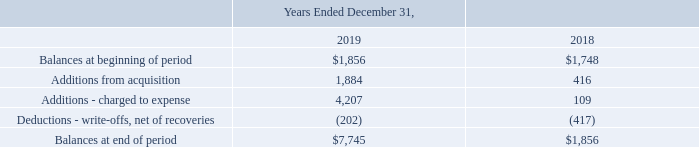ADVANCED ENERGY INDUSTRIES, INC. NOTES TO CONSOLIDATED FINANCIAL STATEMENTS – (continued) (in thousands, except per share amounts)
We have established an allowance for doubtful accounts based upon factors surrounding the credit risk of specific customers, historical trends, and other information.
Accounts Receivable and Allowance for Doubtful Accounts — Accounts receivable are recorded at net realizable value. We maintain a credit approval process and we make significant judgments in connection with assessing our customers’ ability to pay. Despite this assessment, from time to time, our customers are unable to meet their payment obligations. We continuously monitor our customers’ credit worthiness and use our judgment in establishing a provision for estimated credit losses based upon our historical experience and any specific customer collection issues that we have identified. While such credit losses have historically been within our expectations and the provisions established, there is no assurance that we will continue to experience the same credit loss rates that we have in the past. For example, in the fourth quarter, we increased our allowance for doubtful accounts by $4.2 million relating to a customer exposure in China resulting from economic softness and funding delays causing uncertainty in large program timing which uncertainty is now exacerbated by the spreading Coronavirus. A significant change in the liquidity or financial position of our customers could have a material adverse impact on the collectability of accounts receivable and our future operating results.
Changes in allowance for doubtful accounts are summarized as follows:
What was the balance at the beginning of the period of 2019?
Answer scale should be: thousand. $1,856. What was the  Additions from acquisition of 2018?
Answer scale should be: thousand. 1,884. How did the company establish an allowance for doubtful accounts? Based upon factors surrounding the credit risk of specific customers, historical trends, and other information. What were the changes in Additions from acquisition between 2018 and 2019?
Answer scale should be: thousand. 1,884-416
Answer: 1468. What was the change in balances at the end of period between 2018 and 2019?
Answer scale should be: thousand. $7,745-$1,856
Answer: 5889. What was the percentage change in the balances at beginning of period between 2018 and 2019?
Answer scale should be: percent. ($1,856-$1,748)/$1,748
Answer: 6.18. 